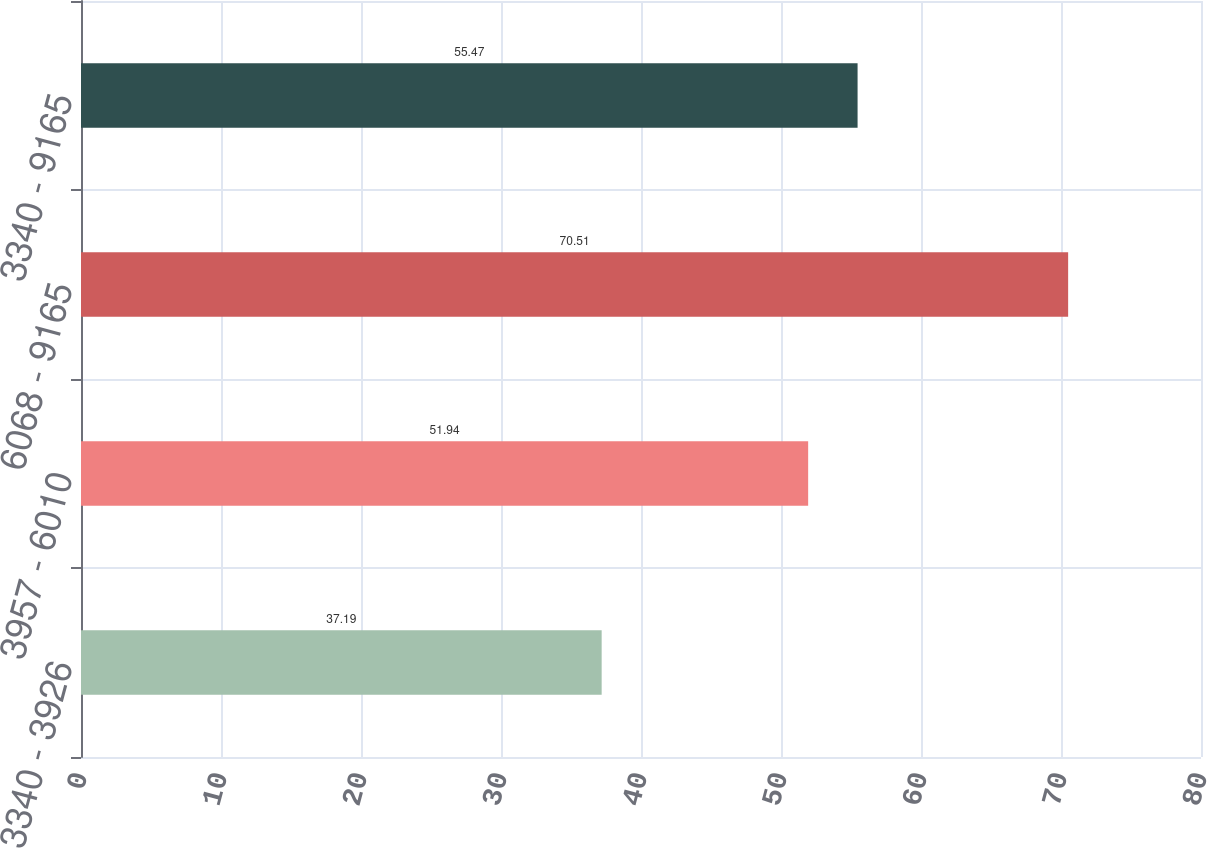Convert chart to OTSL. <chart><loc_0><loc_0><loc_500><loc_500><bar_chart><fcel>3340 - 3926<fcel>3957 - 6010<fcel>6068 - 9165<fcel>3340 - 9165<nl><fcel>37.19<fcel>51.94<fcel>70.51<fcel>55.47<nl></chart> 